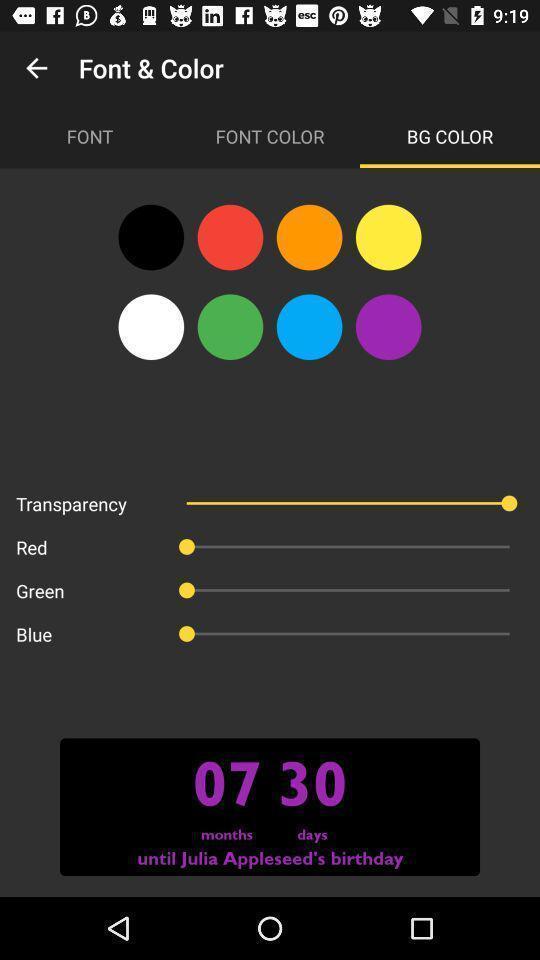Provide a detailed account of this screenshot. Screen displaying different colors to select one. 